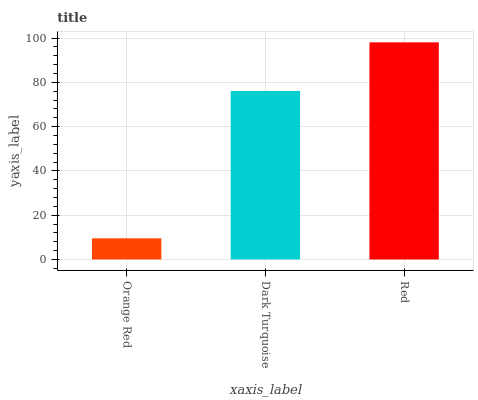Is Orange Red the minimum?
Answer yes or no. Yes. Is Red the maximum?
Answer yes or no. Yes. Is Dark Turquoise the minimum?
Answer yes or no. No. Is Dark Turquoise the maximum?
Answer yes or no. No. Is Dark Turquoise greater than Orange Red?
Answer yes or no. Yes. Is Orange Red less than Dark Turquoise?
Answer yes or no. Yes. Is Orange Red greater than Dark Turquoise?
Answer yes or no. No. Is Dark Turquoise less than Orange Red?
Answer yes or no. No. Is Dark Turquoise the high median?
Answer yes or no. Yes. Is Dark Turquoise the low median?
Answer yes or no. Yes. Is Orange Red the high median?
Answer yes or no. No. Is Orange Red the low median?
Answer yes or no. No. 